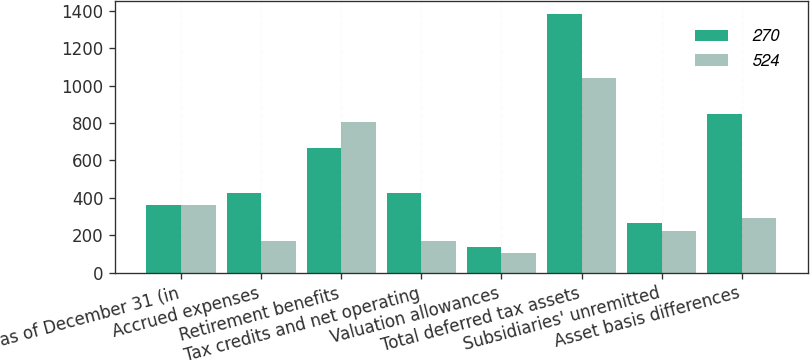Convert chart. <chart><loc_0><loc_0><loc_500><loc_500><stacked_bar_chart><ecel><fcel>as of December 31 (in<fcel>Accrued expenses<fcel>Retirement benefits<fcel>Tax credits and net operating<fcel>Valuation allowances<fcel>Total deferred tax assets<fcel>Subsidiaries' unremitted<fcel>Asset basis differences<nl><fcel>270<fcel>360<fcel>426<fcel>669<fcel>426<fcel>137<fcel>1384<fcel>265<fcel>849<nl><fcel>524<fcel>360<fcel>171<fcel>804<fcel>169<fcel>104<fcel>1040<fcel>222<fcel>294<nl></chart> 